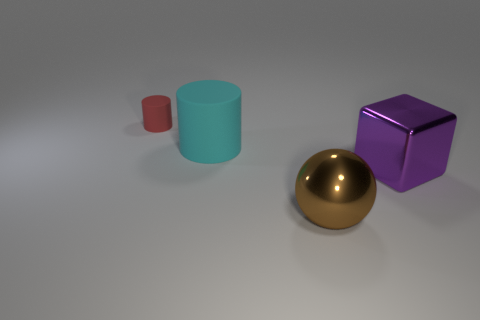Does the red thing have the same shape as the large purple object? No, the red thing does not have the same shape as the large purple object. The red object appears to be a smaller cylinder, while the large purple object is a cube. 